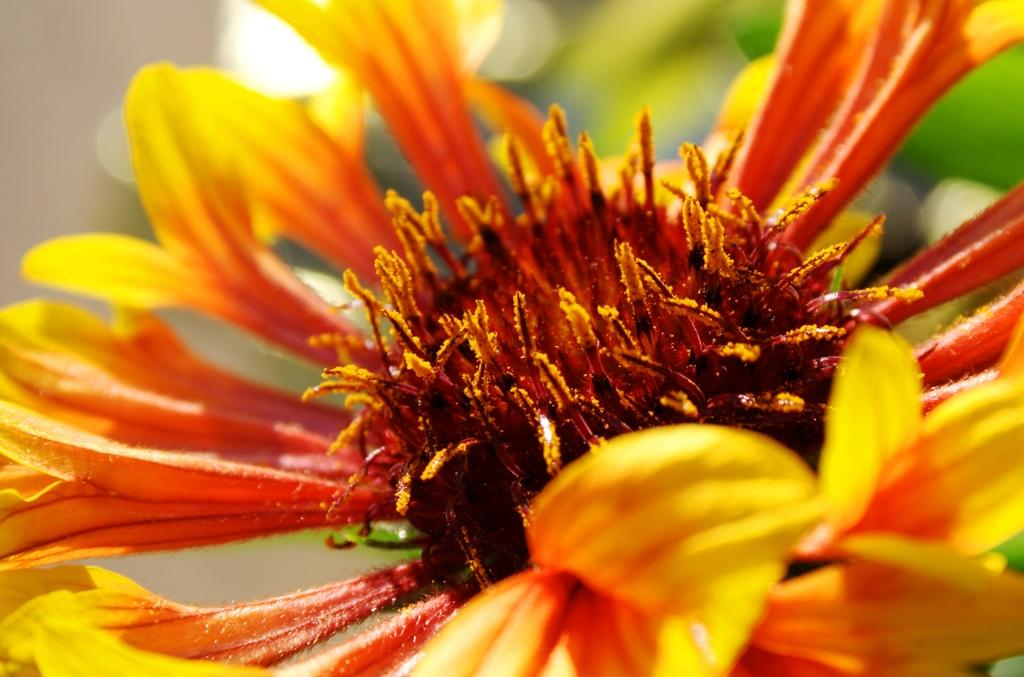What is the main subject of the image? There is a flower in the image. Can you describe the colors of the flower? The flower has orange and yellow colors. What type of cloud can be seen in the image? There is no cloud present in the image; it features a flower with orange and yellow colors. What role does the parent play in the image? There is no parent present in the image, as it only features a flower. 